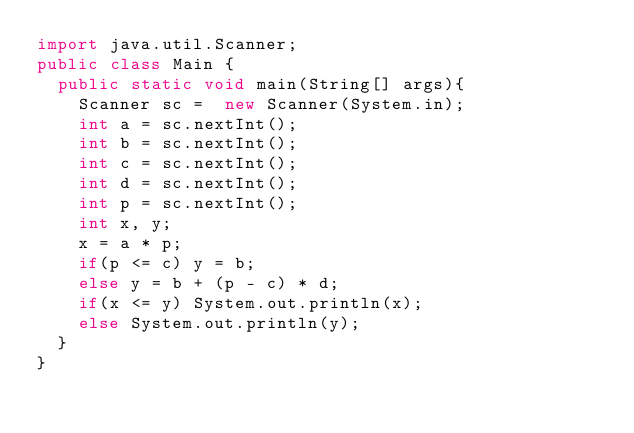<code> <loc_0><loc_0><loc_500><loc_500><_Java_>import java.util.Scanner;
public class Main {
	public static void main(String[] args){
		Scanner sc =  new Scanner(System.in);
		int a = sc.nextInt();
		int b = sc.nextInt();
		int c = sc.nextInt();
		int d = sc.nextInt();
		int p = sc.nextInt();
		int x, y;
		x = a * p;
		if(p <= c) y = b;
		else y = b + (p - c) * d;
		if(x <= y) System.out.println(x);
		else System.out.println(y);
	}
}</code> 